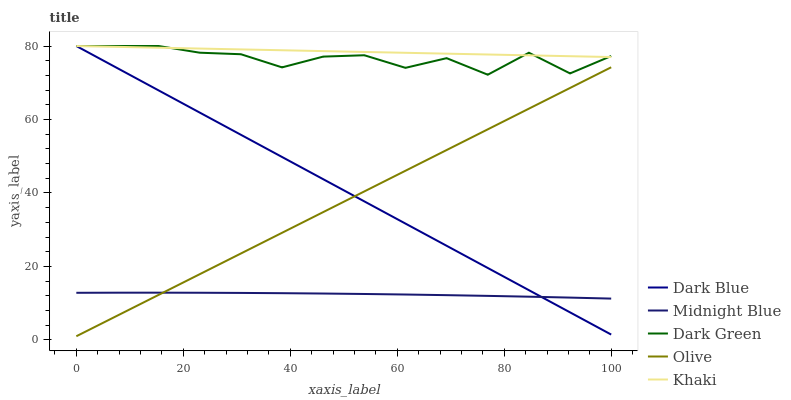Does Midnight Blue have the minimum area under the curve?
Answer yes or no. Yes. Does Khaki have the maximum area under the curve?
Answer yes or no. Yes. Does Dark Blue have the minimum area under the curve?
Answer yes or no. No. Does Dark Blue have the maximum area under the curve?
Answer yes or no. No. Is Olive the smoothest?
Answer yes or no. Yes. Is Dark Green the roughest?
Answer yes or no. Yes. Is Dark Blue the smoothest?
Answer yes or no. No. Is Dark Blue the roughest?
Answer yes or no. No. Does Olive have the lowest value?
Answer yes or no. Yes. Does Dark Blue have the lowest value?
Answer yes or no. No. Does Dark Green have the highest value?
Answer yes or no. Yes. Does Midnight Blue have the highest value?
Answer yes or no. No. Is Midnight Blue less than Dark Green?
Answer yes or no. Yes. Is Khaki greater than Olive?
Answer yes or no. Yes. Does Dark Green intersect Dark Blue?
Answer yes or no. Yes. Is Dark Green less than Dark Blue?
Answer yes or no. No. Is Dark Green greater than Dark Blue?
Answer yes or no. No. Does Midnight Blue intersect Dark Green?
Answer yes or no. No. 